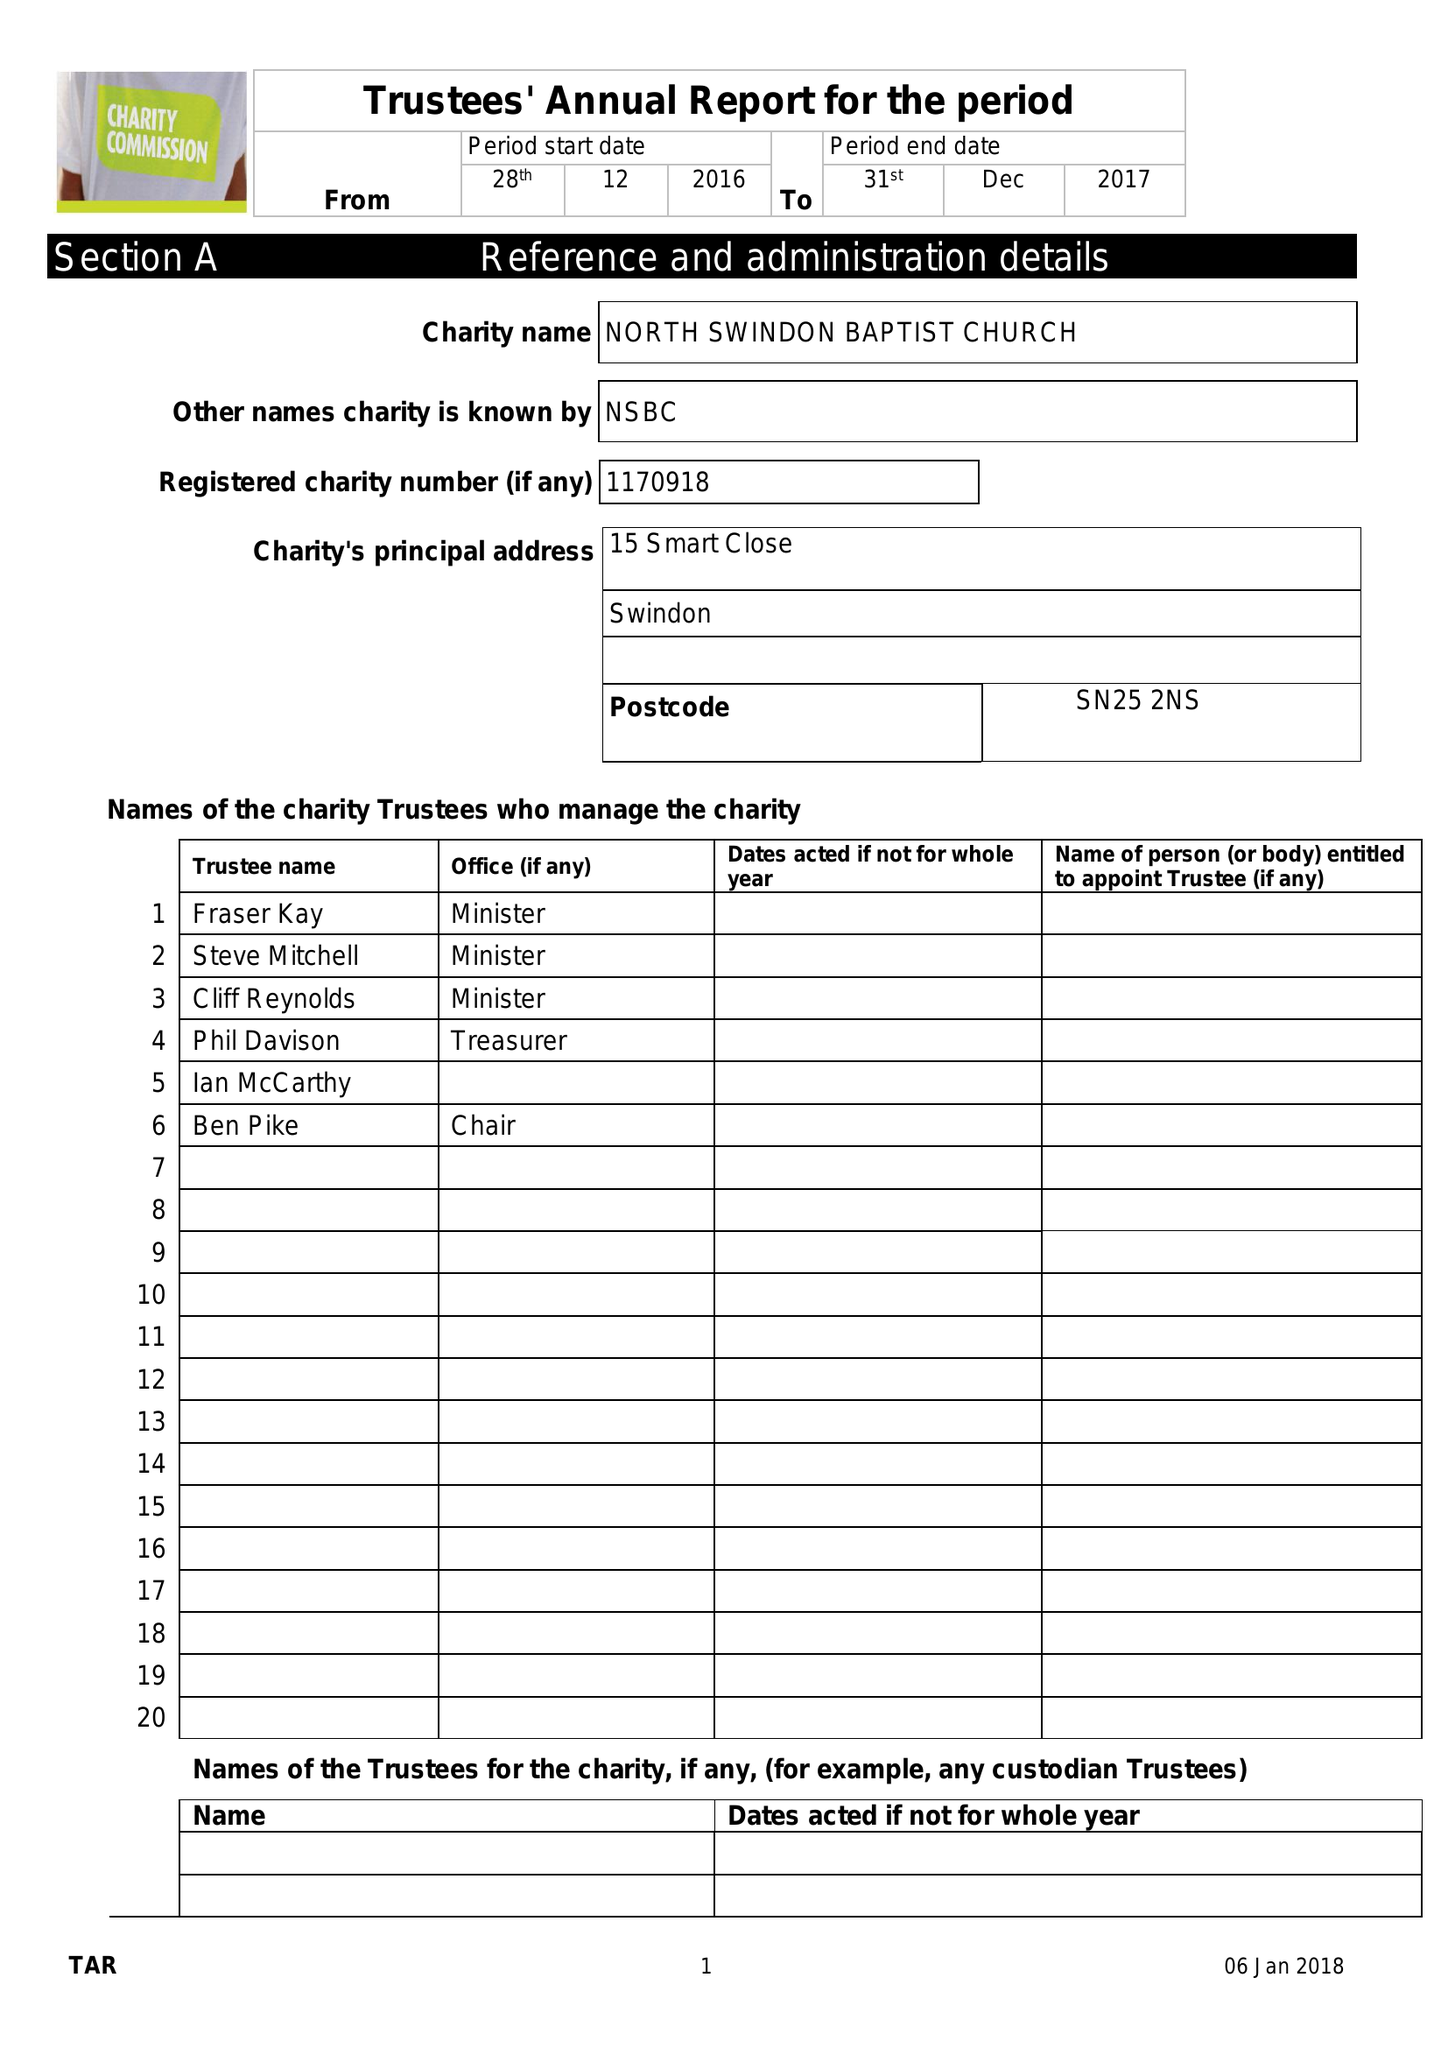What is the value for the address__post_town?
Answer the question using a single word or phrase. SWINDON 